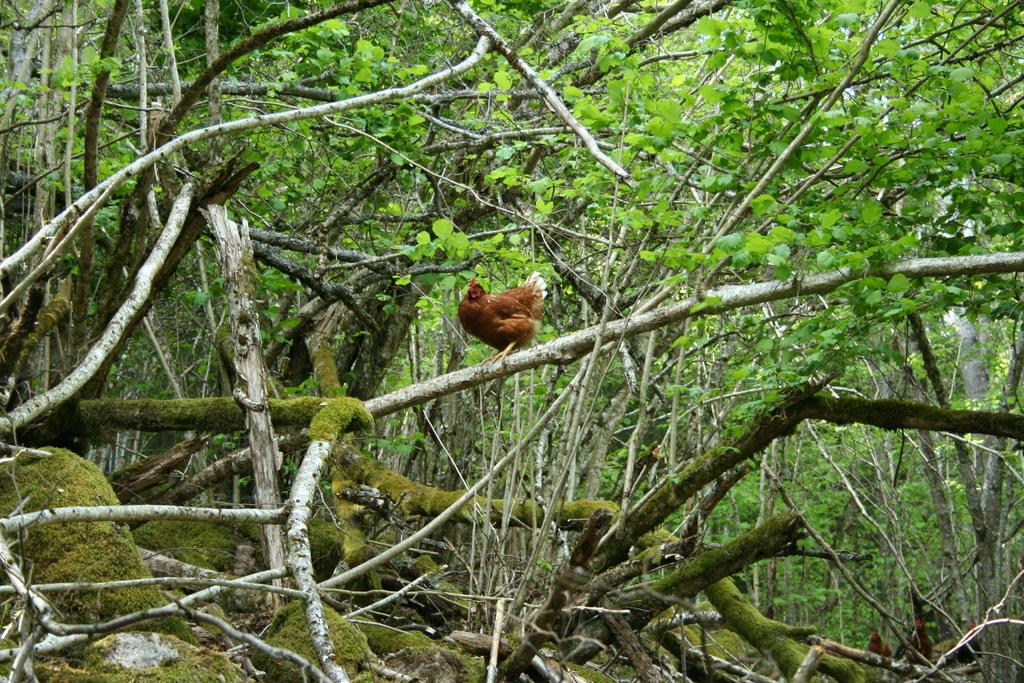What animal is present in the image? There is a hen in the image. Where is the hen located? The hen is standing on a branch of a tree. What can be seen around the hen? There are trees around the hen. What type of rose is the man holding in the image? There is no man or rose present in the image; it features a hen standing on a tree branch. 